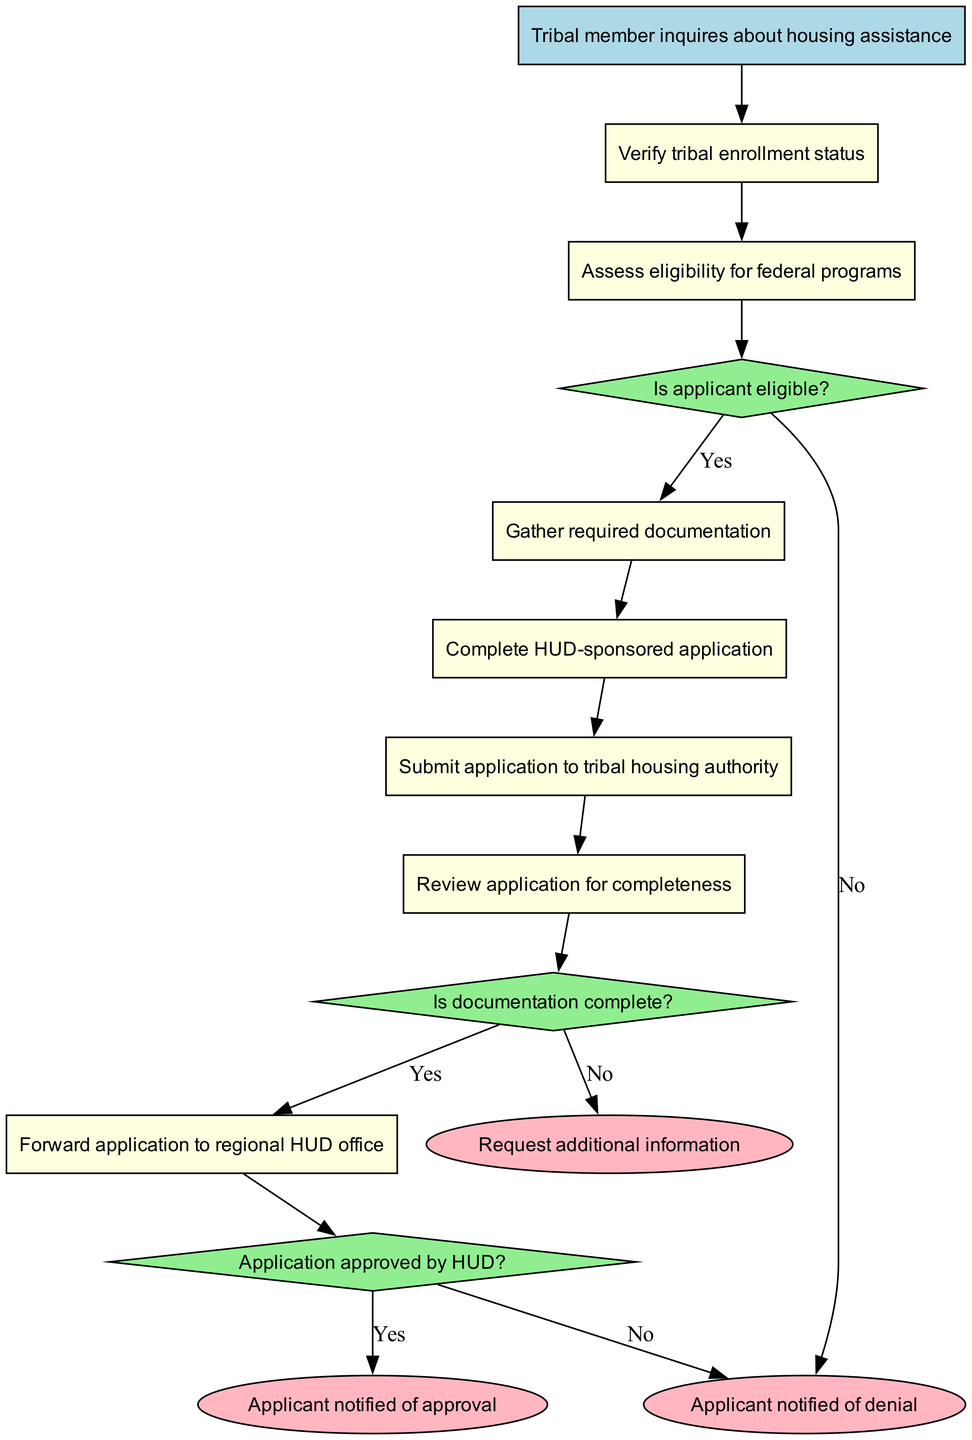What is the starting point of the application process? The starting point of the process is indicated by the first node, labeled "Tribal member inquires about housing assistance."
Answer: Tribal member inquires about housing assistance How many decision nodes are in the diagram? The diagram shows three decision nodes, each leading to different next steps depending on the answer.
Answer: 3 What happens if the applicant is found ineligible? The flow chart indicates that if the applicant is found ineligible, the process ends as specified in the connection labeling.
Answer: End process Which process follows "Verify tribal enrollment status"? The next process, following "Verify tribal enrollment status," is "Assess eligibility for federal programs." This is shown by the connection leading from the first process to the second one.
Answer: Assess eligibility for federal programs If the documentation is incomplete, what action is requested? According to the connections in the flow chart, if the documentation is incomplete, a request for more information is sent as the next step.
Answer: Request additional information What is the outcome if the application is approved by HUD? If the application is approved by HUD, the subsequent action is to notify the applicant, as shown in the final part of the flow chart's connections.
Answer: Applicant notified of approval What are the two possibilities after the application review for completeness? After reviewing the application for completeness, the two possibilities are either that the documentation is complete or incomplete, leading to different next steps.
Answer: Complete or incomplete What does the flow lead to if the applicant's documentation is complete? If the applicant's documentation is complete, the flow leads to submitting the application to HUD as shown by the connections in the chart.
Answer: Submit application to HUD What type of shape represents the decision nodes in the diagram? The decision nodes in the diagram are represented by diamond shapes, which is a standard shape for decision-making points in flow charts.
Answer: Diamond 